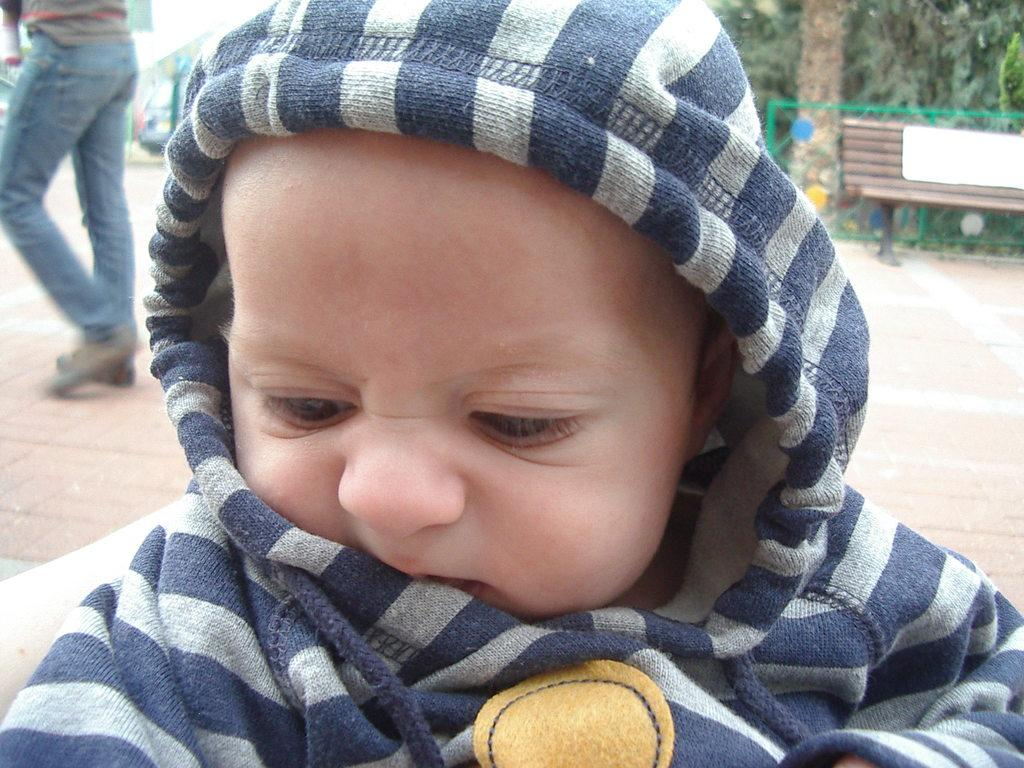What is the main subject of the image? There is a kid in the image. What is the kid wearing? The kid is wearing a blue and white sweater. Can you describe the person behind the kid? There is a person walking behind the kid. What type of seating is present in the image? There is a bench in the image. What type of vegetation can be seen in the image? There are trees in the image. How does the spoon increase in size as the image progresses? There is no spoon present in the image, so it cannot increase in size. 